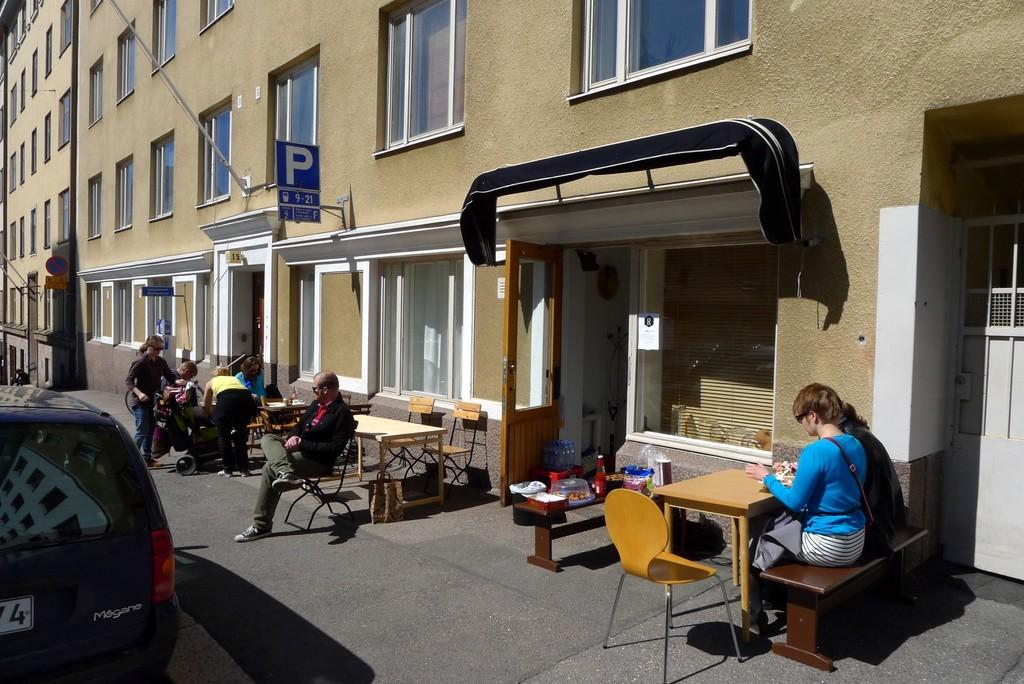What are the people in the image doing? The people in the image are sitting on chairs in the road. What are the chairs placed in front of? There are tables in front of the chairs. What can be seen in the background of the image? There is a building near the people. What type of mask is the government wearing in the image? There is no mention of a mask or government in the image; it features people sitting on chairs in the road with tables in front of them. 